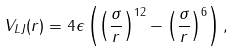Convert formula to latex. <formula><loc_0><loc_0><loc_500><loc_500>V _ { L J } ( r ) = 4 \epsilon \left ( \left ( \frac { \sigma } { r } \right ) ^ { 1 2 } - \left ( \frac { \sigma } { r } \right ) ^ { 6 } \right ) ,</formula> 